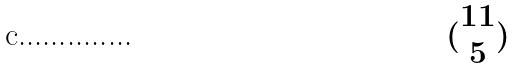<formula> <loc_0><loc_0><loc_500><loc_500>( \begin{matrix} 1 1 \\ 5 \end{matrix} )</formula> 